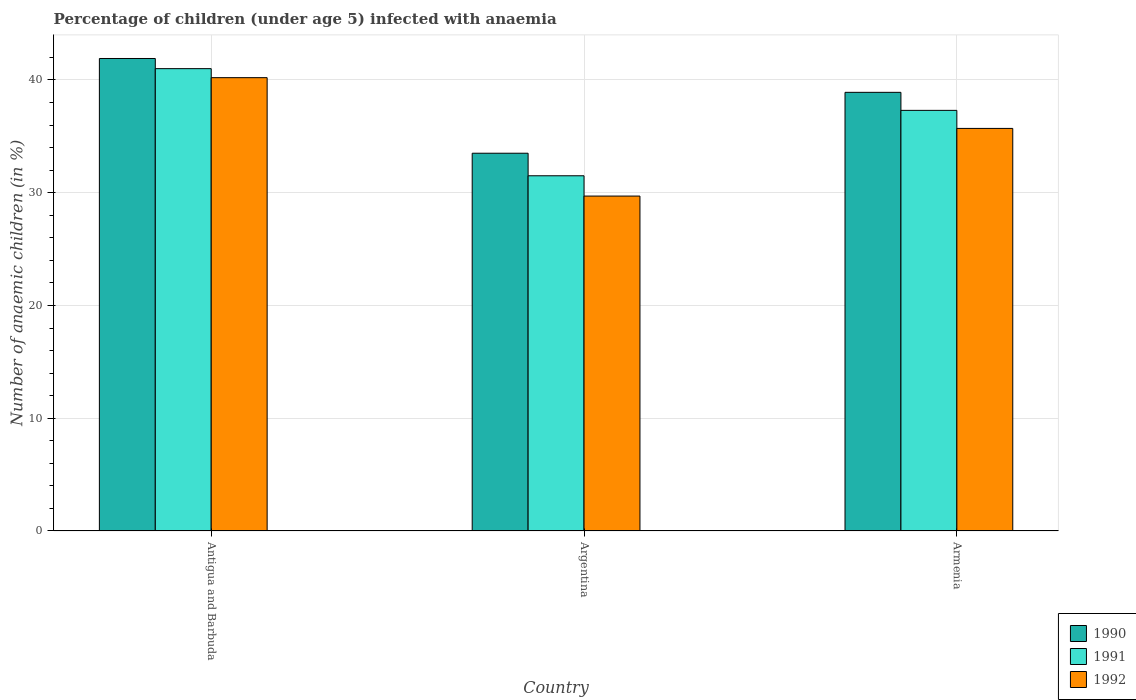Are the number of bars per tick equal to the number of legend labels?
Provide a succinct answer. Yes. Are the number of bars on each tick of the X-axis equal?
Offer a terse response. Yes. How many bars are there on the 3rd tick from the right?
Offer a very short reply. 3. What is the percentage of children infected with anaemia in in 1992 in Argentina?
Offer a terse response. 29.7. Across all countries, what is the minimum percentage of children infected with anaemia in in 1991?
Your response must be concise. 31.5. In which country was the percentage of children infected with anaemia in in 1990 maximum?
Make the answer very short. Antigua and Barbuda. What is the total percentage of children infected with anaemia in in 1990 in the graph?
Offer a very short reply. 114.3. What is the difference between the percentage of children infected with anaemia in in 1991 in Antigua and Barbuda and that in Argentina?
Your answer should be very brief. 9.5. What is the difference between the percentage of children infected with anaemia in in 1990 in Antigua and Barbuda and the percentage of children infected with anaemia in in 1992 in Armenia?
Offer a terse response. 6.2. What is the average percentage of children infected with anaemia in in 1991 per country?
Your answer should be compact. 36.6. What is the difference between the percentage of children infected with anaemia in of/in 1991 and percentage of children infected with anaemia in of/in 1992 in Argentina?
Your answer should be very brief. 1.8. In how many countries, is the percentage of children infected with anaemia in in 1992 greater than 6 %?
Provide a succinct answer. 3. What is the ratio of the percentage of children infected with anaemia in in 1990 in Antigua and Barbuda to that in Armenia?
Provide a short and direct response. 1.08. What is the difference between the highest and the second highest percentage of children infected with anaemia in in 1990?
Your answer should be very brief. 3. What is the difference between the highest and the lowest percentage of children infected with anaemia in in 1990?
Your answer should be compact. 8.4. In how many countries, is the percentage of children infected with anaemia in in 1992 greater than the average percentage of children infected with anaemia in in 1992 taken over all countries?
Make the answer very short. 2. How many bars are there?
Provide a succinct answer. 9. Does the graph contain any zero values?
Offer a terse response. No. What is the title of the graph?
Offer a terse response. Percentage of children (under age 5) infected with anaemia. What is the label or title of the X-axis?
Offer a terse response. Country. What is the label or title of the Y-axis?
Your answer should be compact. Number of anaemic children (in %). What is the Number of anaemic children (in %) in 1990 in Antigua and Barbuda?
Provide a succinct answer. 41.9. What is the Number of anaemic children (in %) of 1992 in Antigua and Barbuda?
Your response must be concise. 40.2. What is the Number of anaemic children (in %) of 1990 in Argentina?
Provide a succinct answer. 33.5. What is the Number of anaemic children (in %) in 1991 in Argentina?
Your answer should be compact. 31.5. What is the Number of anaemic children (in %) of 1992 in Argentina?
Your response must be concise. 29.7. What is the Number of anaemic children (in %) of 1990 in Armenia?
Provide a succinct answer. 38.9. What is the Number of anaemic children (in %) in 1991 in Armenia?
Offer a very short reply. 37.3. What is the Number of anaemic children (in %) in 1992 in Armenia?
Give a very brief answer. 35.7. Across all countries, what is the maximum Number of anaemic children (in %) in 1990?
Make the answer very short. 41.9. Across all countries, what is the maximum Number of anaemic children (in %) in 1992?
Offer a terse response. 40.2. Across all countries, what is the minimum Number of anaemic children (in %) in 1990?
Make the answer very short. 33.5. Across all countries, what is the minimum Number of anaemic children (in %) of 1991?
Provide a succinct answer. 31.5. Across all countries, what is the minimum Number of anaemic children (in %) of 1992?
Your answer should be compact. 29.7. What is the total Number of anaemic children (in %) in 1990 in the graph?
Give a very brief answer. 114.3. What is the total Number of anaemic children (in %) in 1991 in the graph?
Your answer should be very brief. 109.8. What is the total Number of anaemic children (in %) in 1992 in the graph?
Your response must be concise. 105.6. What is the difference between the Number of anaemic children (in %) in 1990 in Antigua and Barbuda and that in Argentina?
Your response must be concise. 8.4. What is the difference between the Number of anaemic children (in %) of 1991 in Antigua and Barbuda and that in Armenia?
Offer a very short reply. 3.7. What is the difference between the Number of anaemic children (in %) of 1992 in Antigua and Barbuda and that in Armenia?
Keep it short and to the point. 4.5. What is the difference between the Number of anaemic children (in %) of 1990 in Argentina and that in Armenia?
Provide a short and direct response. -5.4. What is the difference between the Number of anaemic children (in %) of 1991 in Antigua and Barbuda and the Number of anaemic children (in %) of 1992 in Argentina?
Offer a terse response. 11.3. What is the difference between the Number of anaemic children (in %) of 1991 in Antigua and Barbuda and the Number of anaemic children (in %) of 1992 in Armenia?
Make the answer very short. 5.3. What is the average Number of anaemic children (in %) of 1990 per country?
Your answer should be compact. 38.1. What is the average Number of anaemic children (in %) in 1991 per country?
Offer a very short reply. 36.6. What is the average Number of anaemic children (in %) in 1992 per country?
Provide a short and direct response. 35.2. What is the difference between the Number of anaemic children (in %) of 1990 and Number of anaemic children (in %) of 1991 in Antigua and Barbuda?
Keep it short and to the point. 0.9. What is the difference between the Number of anaemic children (in %) of 1991 and Number of anaemic children (in %) of 1992 in Antigua and Barbuda?
Ensure brevity in your answer.  0.8. What is the difference between the Number of anaemic children (in %) in 1991 and Number of anaemic children (in %) in 1992 in Armenia?
Give a very brief answer. 1.6. What is the ratio of the Number of anaemic children (in %) of 1990 in Antigua and Barbuda to that in Argentina?
Offer a terse response. 1.25. What is the ratio of the Number of anaemic children (in %) of 1991 in Antigua and Barbuda to that in Argentina?
Your answer should be very brief. 1.3. What is the ratio of the Number of anaemic children (in %) in 1992 in Antigua and Barbuda to that in Argentina?
Give a very brief answer. 1.35. What is the ratio of the Number of anaemic children (in %) of 1990 in Antigua and Barbuda to that in Armenia?
Keep it short and to the point. 1.08. What is the ratio of the Number of anaemic children (in %) of 1991 in Antigua and Barbuda to that in Armenia?
Your answer should be very brief. 1.1. What is the ratio of the Number of anaemic children (in %) in 1992 in Antigua and Barbuda to that in Armenia?
Provide a succinct answer. 1.13. What is the ratio of the Number of anaemic children (in %) of 1990 in Argentina to that in Armenia?
Make the answer very short. 0.86. What is the ratio of the Number of anaemic children (in %) in 1991 in Argentina to that in Armenia?
Ensure brevity in your answer.  0.84. What is the ratio of the Number of anaemic children (in %) in 1992 in Argentina to that in Armenia?
Provide a succinct answer. 0.83. What is the difference between the highest and the second highest Number of anaemic children (in %) of 1990?
Provide a short and direct response. 3. What is the difference between the highest and the second highest Number of anaemic children (in %) in 1991?
Your answer should be very brief. 3.7. What is the difference between the highest and the second highest Number of anaemic children (in %) in 1992?
Give a very brief answer. 4.5. What is the difference between the highest and the lowest Number of anaemic children (in %) in 1992?
Ensure brevity in your answer.  10.5. 